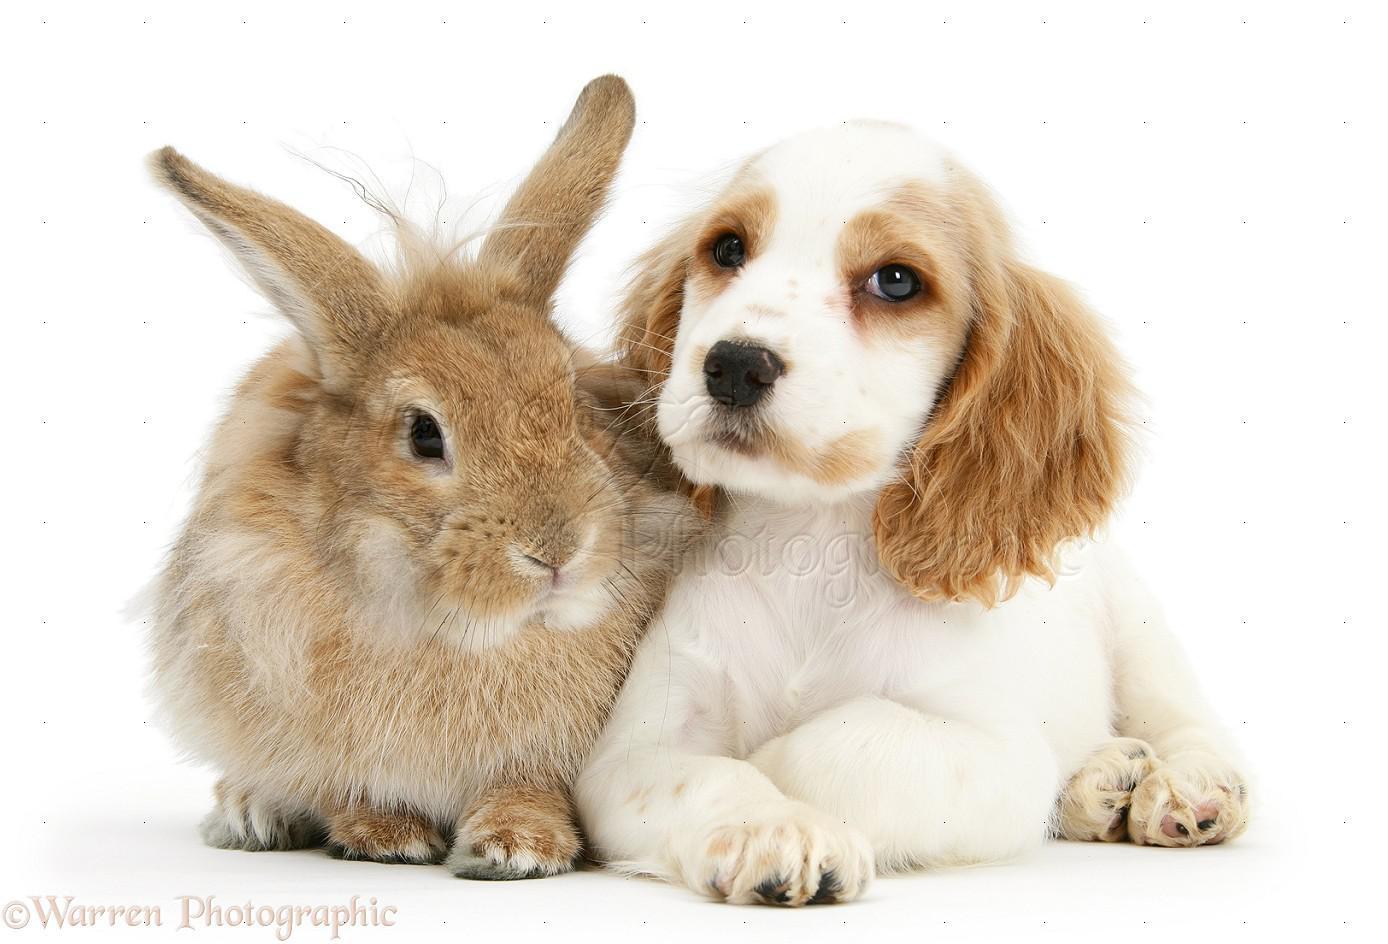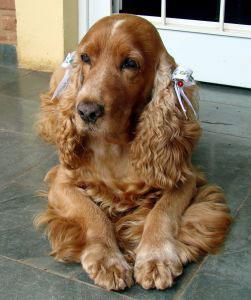The first image is the image on the left, the second image is the image on the right. Evaluate the accuracy of this statement regarding the images: "A dog is sitting with a dog of another species in the image on the left.". Is it true? Answer yes or no. Yes. The first image is the image on the left, the second image is the image on the right. Assess this claim about the two images: "A spaniel puppy is posed next to a different animal pet in the left image, and the right image shows an orange spaniel with front paws forward.". Correct or not? Answer yes or no. Yes. 